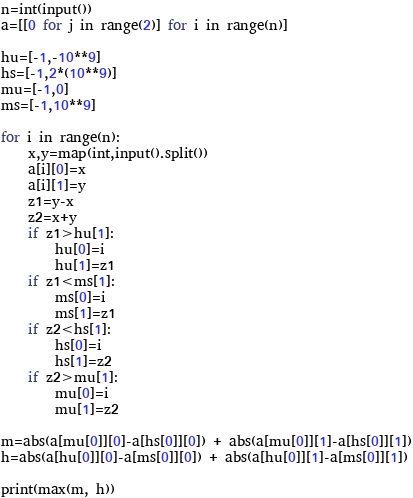Convert code to text. <code><loc_0><loc_0><loc_500><loc_500><_Python_>n=int(input())
a=[[0 for j in range(2)] for i in range(n)]

hu=[-1,-10**9]
hs=[-1,2*(10**9)]
mu=[-1,0]
ms=[-1,10**9]

for i in range(n):
    x,y=map(int,input().split())
    a[i][0]=x
    a[i][1]=y
    z1=y-x
    z2=x+y
    if z1>hu[1]:
        hu[0]=i
        hu[1]=z1
    if z1<ms[1]:
        ms[0]=i
        ms[1]=z1
    if z2<hs[1]:
        hs[0]=i
        hs[1]=z2
    if z2>mu[1]:
        mu[0]=i
        mu[1]=z2

m=abs(a[mu[0]][0]-a[hs[0]][0]) + abs(a[mu[0]][1]-a[hs[0]][1])
h=abs(a[hu[0]][0]-a[ms[0]][0]) + abs(a[hu[0]][1]-a[ms[0]][1])

print(max(m, h))
</code> 